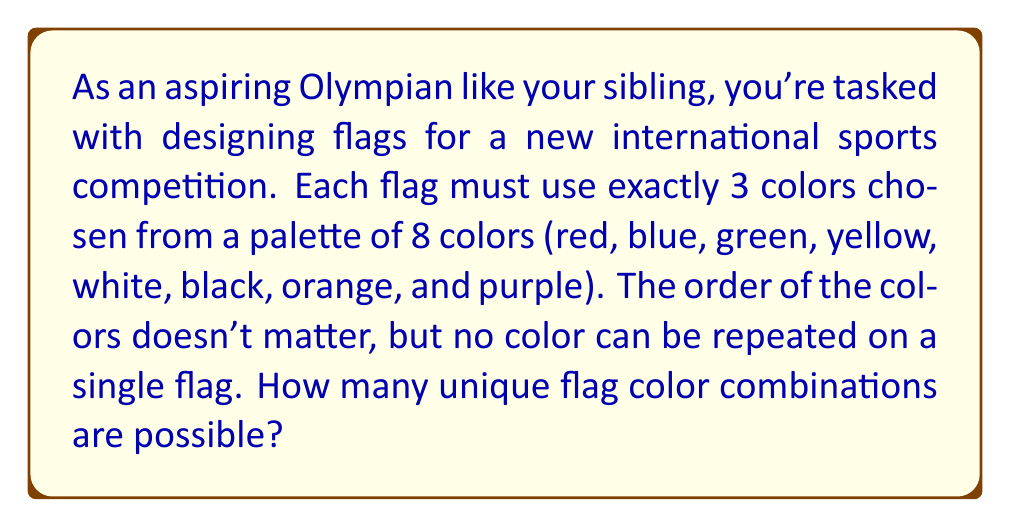Provide a solution to this math problem. Let's approach this step-by-step:

1) This is a combination problem. We're selecting 3 colors from 8 available colors, where the order doesn't matter and repetition is not allowed.

2) The formula for combinations without repetition is:

   $$C(n,r) = \frac{n!}{r!(n-r)!}$$

   Where $n$ is the total number of items to choose from, and $r$ is the number of items being chosen.

3) In this case, $n = 8$ (total colors) and $r = 3$ (colors per flag).

4) Plugging these values into our formula:

   $$C(8,3) = \frac{8!}{3!(8-3)!} = \frac{8!}{3!5!}$$

5) Let's calculate this:
   
   $$\frac{8 * 7 * 6 * 5!}{(3 * 2 * 1) * 5!}$$

6) The $5!$ cancels out in the numerator and denominator:

   $$\frac{8 * 7 * 6}{3 * 2 * 1} = \frac{336}{6} = 56$$

Therefore, there are 56 possible unique flag color combinations.
Answer: 56 unique flag color combinations 